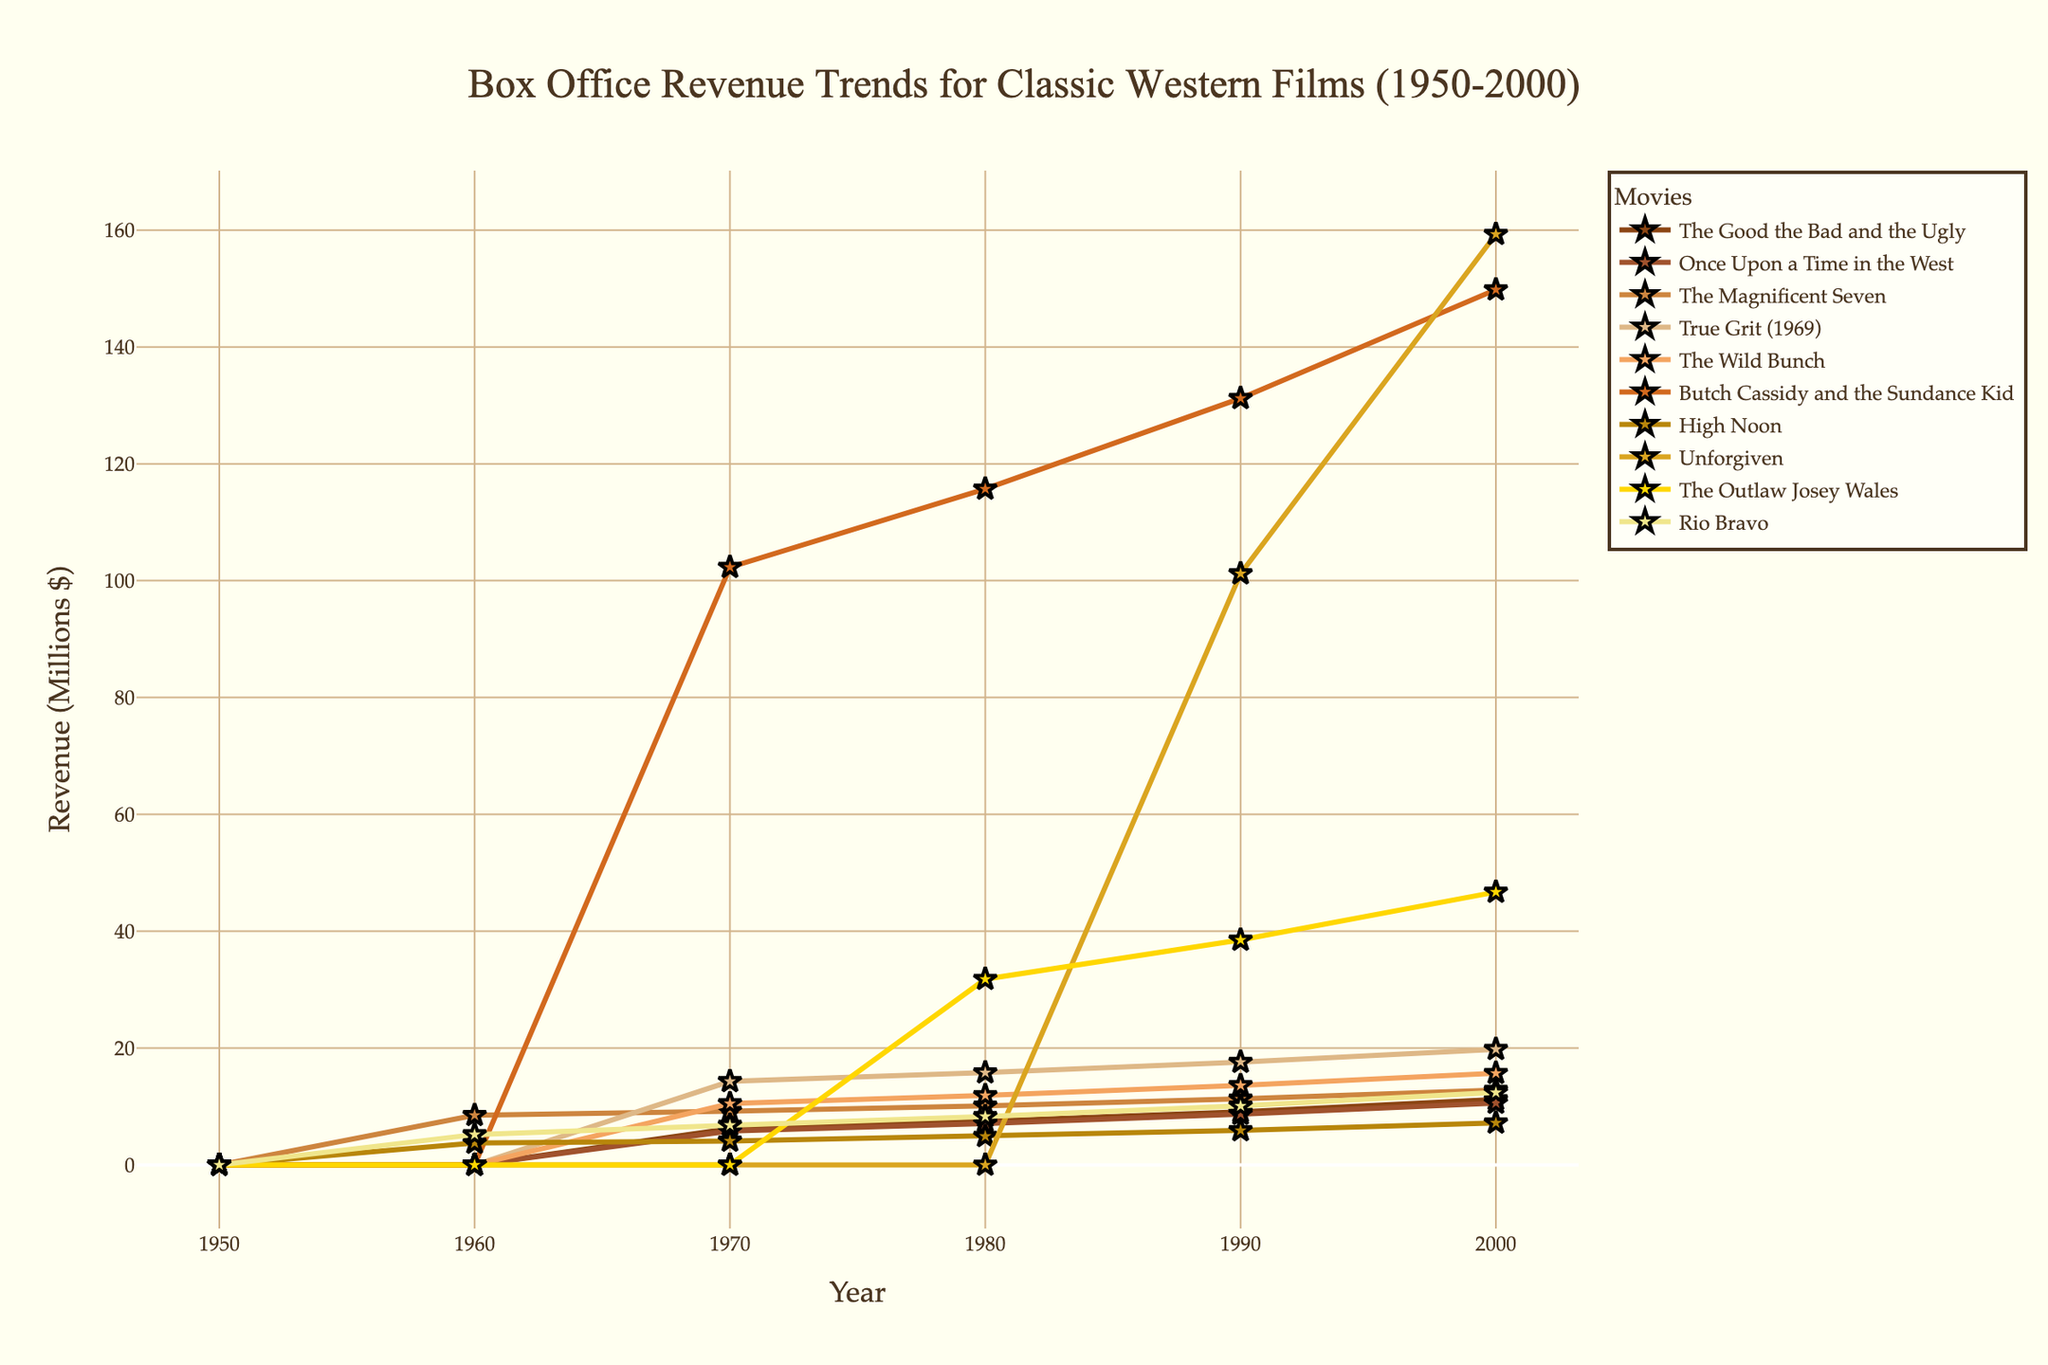What's the trend for "The Good the Bad and the Ugly" from 1950 to 2000? From 1950 to 1960, the revenue is zero. It starts at 6.2 million in 1970, 7.5 million in 1980, 9.1 million in 1990, and reaches 11.2 million in 2000. Thus, the trend is an increase in revenue over time.
Answer: Increasing trend Which movie had the highest revenue in 2000? By looking at the 2000 revenue values, "Butch Cassidy and the Sundance Kid" has the highest revenue of 149.8 million.
Answer: Butch Cassidy and the Sundance Kid How did "Unforgiven" perform in the 1990s compared to the 2000s? In 1990, "Unforgiven"'s revenue was 101.2 million, and by the 2000s, it increased to 159.3 million. Thus, it performed better in the 2000s.
Answer: Better in the 2000s What is the average revenue for "The Magnificent Seven" across all years? The revenues for "The Magnificent Seven" across the years are 8.5, 9.2, 10.1, 11.3, and 12.8 million. The sum is 51.9 million, divided by 5 gives an average of 10.38 million.
Answer: 10.38 million Which movie shows the greatest revenue increase from 1960 to 2000? For each movie, calculate the difference between the 2000 and 1960 values. "Butch Cassidy and the Sundance Kid" shows the greatest increase from 0 in 1960 to 149.8 million in 2000, an increase of 149.8 million.
Answer: Butch Cassidy and the Sundance Kid How do the revenues of "High Noon" and "The Outlaw Josey Wales" compare in 1980? In 1980, "High Noon" has a revenue of 4.9 million, and "The Outlaw Josey Wales" has a revenue of 31.8 million. "The Outlaw Josey Wales" has a higher revenue.
Answer: The Outlaw Josey Wales has higher revenue What is the total revenue for "True Grit (1969)" over the years? The revenues are 0, 14.3, 15.8, 17.6, and 19.8 million. The total revenue is the sum: 67.5 million.
Answer: 67.5 million Did "Rio Bravo" ever surpass "The Magnificent Seven" in revenue at any point? By comparing their revenue values across all years, no year shows "Rio Bravo" surpassing "The Magnificent Seven". "The Magnificent Seven" always has higher revenue values.
Answer: No Which movie had a consistent increase in revenue every decade? "Butch Cassidy and the Sundance Kid" shows a consistent increase every decade: 0 (1950s), 0 (1960s), 102.3 (1970s), 115.7 (1980s), 131.2 (1990s), 149.8 (2000s).
Answer: Butch Cassidy and the Sundance Kid 